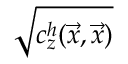Convert formula to latex. <formula><loc_0><loc_0><loc_500><loc_500>\sqrt { c _ { z } ^ { h } ( \vec { x } , \vec { x } ) }</formula> 